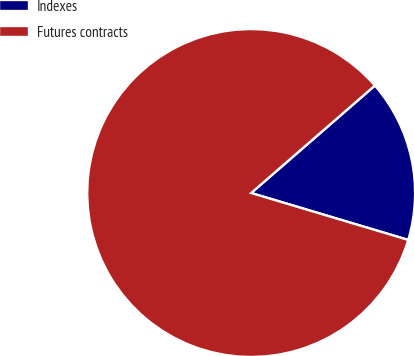Convert chart. <chart><loc_0><loc_0><loc_500><loc_500><pie_chart><fcel>Indexes<fcel>Futures contracts<nl><fcel>16.0%<fcel>84.0%<nl></chart> 